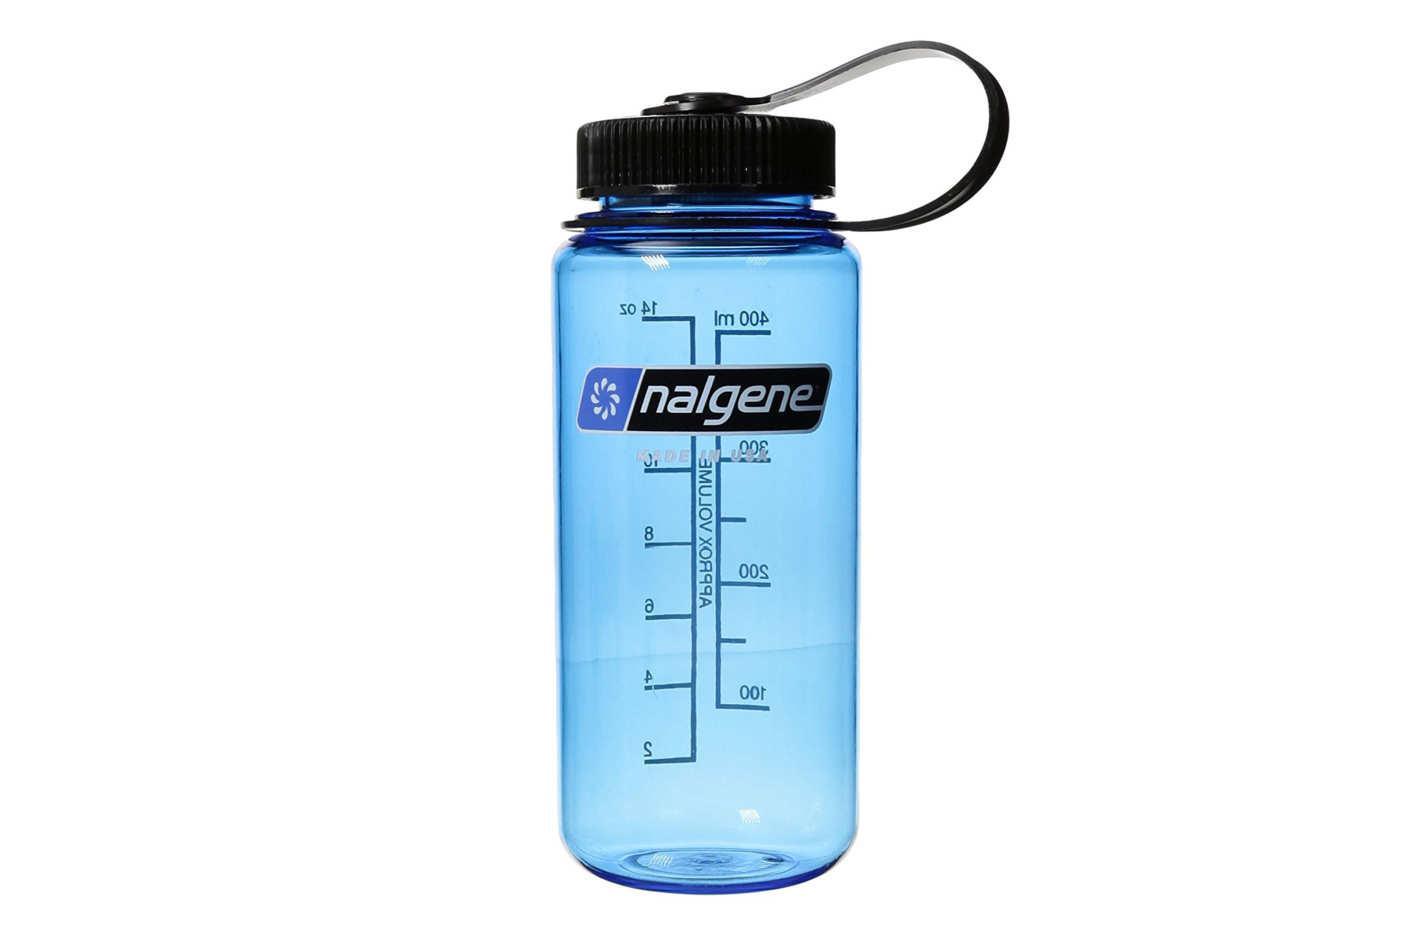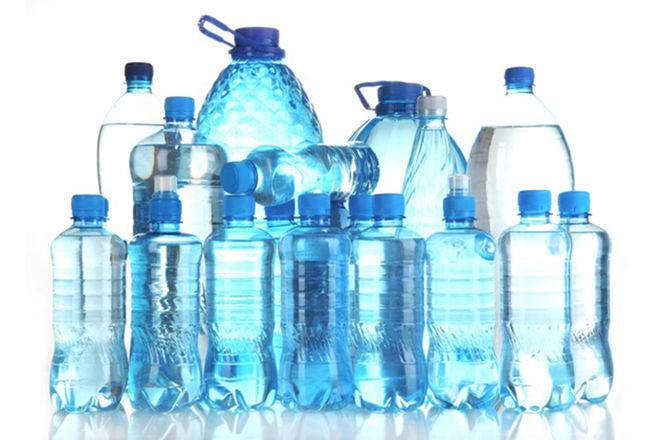The first image is the image on the left, the second image is the image on the right. Analyze the images presented: Is the assertion "A clear blue water bottle has a black top with loop." valid? Answer yes or no. Yes. The first image is the image on the left, the second image is the image on the right. Evaluate the accuracy of this statement regarding the images: "There is exactly one water bottle in the image on the left.". Is it true? Answer yes or no. Yes. The first image is the image on the left, the second image is the image on the right. Given the left and right images, does the statement "An image shows one sport-type water bottle with a loop on the lid." hold true? Answer yes or no. Yes. 